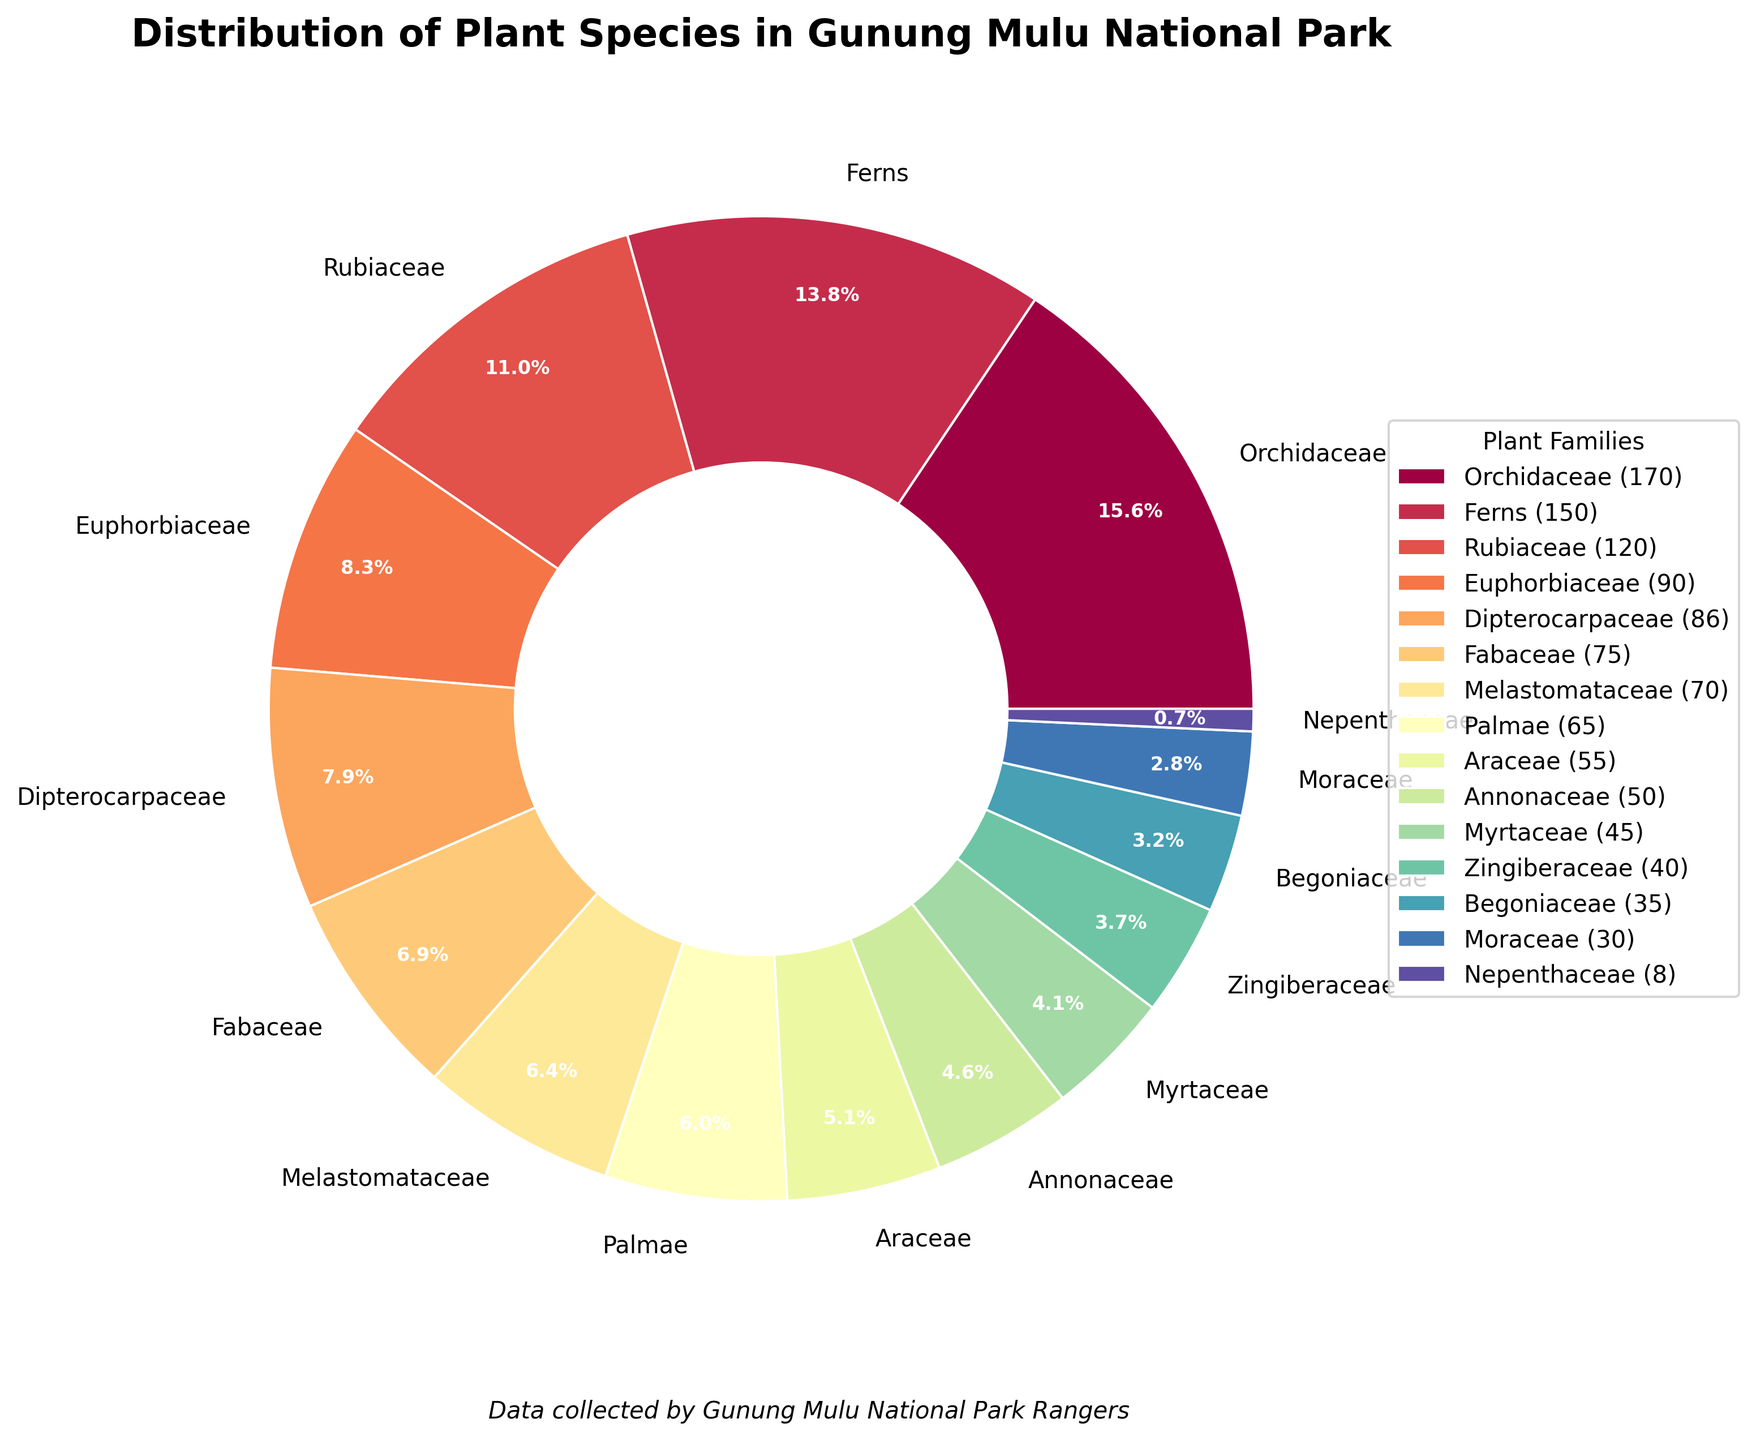Which plant family has the highest number of species? The number of species in each family is shown in the pie chart. The family with the largest wedge area and highest percentage label (33.1%) is Orchidaceae with 170 species.
Answer: Orchidaceae What percentage of plant species in the park belongs to the Dipterocarpaceae family? Refer to the pie chart and find the label with "Dipterocarpaceae". The associated percentage is displayed beside the wedge; it shows 16.8%.
Answer: 16.8% How many more species are there in the Rubiaceae family compared to the Begoniaceae family? Find the species counts for Rubiaceae (120 species) and Begoniaceae (35 species). Subtract the number of species in Begoniaceae from Rubiaceae (120 - 35).
Answer: 85 What is the total number of plant species represented in the pie chart? Sum up the species counts from all families: 170 (Orchidaceae) + 150 (Ferns) + 120 (Rubiaceae) + 90 (Euphorbiaceae) + 86 (Dipterocarpaceae) + 75 (Fabaceae) + 70 (Melastomataceae) + 65 (Palmae) + 55 (Araceae) + 50 (Annonaceae) + 45 (Myrtaceae) + 40 (Zingiberaceae) + 35 (Begoniaceae) + 30 (Moraceae) + 8 (Nepenthaceae). This equals 1089 species.
Answer: 1089 Which two families have the closest number of species to each other, and what is the difference? Compare the species counts: Myrtaceae (45) and Zingiberaceae (40) have the closest numbers. The difference is 45 - 40 = 5 species.
Answer: Myrtaceae and Zingiberaceae, 5 What fraction of the total plant species is represented by the largest family? The largest family is Orchidaceae with 170 species out of a total of 1089 species. The fraction is 170/1089. Simplify to approximately 0.1561 or 15.6%.
Answer: 15.6% Which family has the smallest representation in the park and what is its species count? The pie chart shows the smallest wedge area and the label with the lowest percentage (0.7%) for Nepenthaceae, which has 8 species.
Answer: Nepenthaceae, 8 If the park's botany team discovered 30 new species belonging to the Araceae family, how would this change its percentage representation? Current species in Araceae: 55. Adding 30 new species gives 85. New total species: 1089 + 30 = 1119. New percentage: (85/1119) * 100 ≈ 7.6%.
Answer: 7.6% 